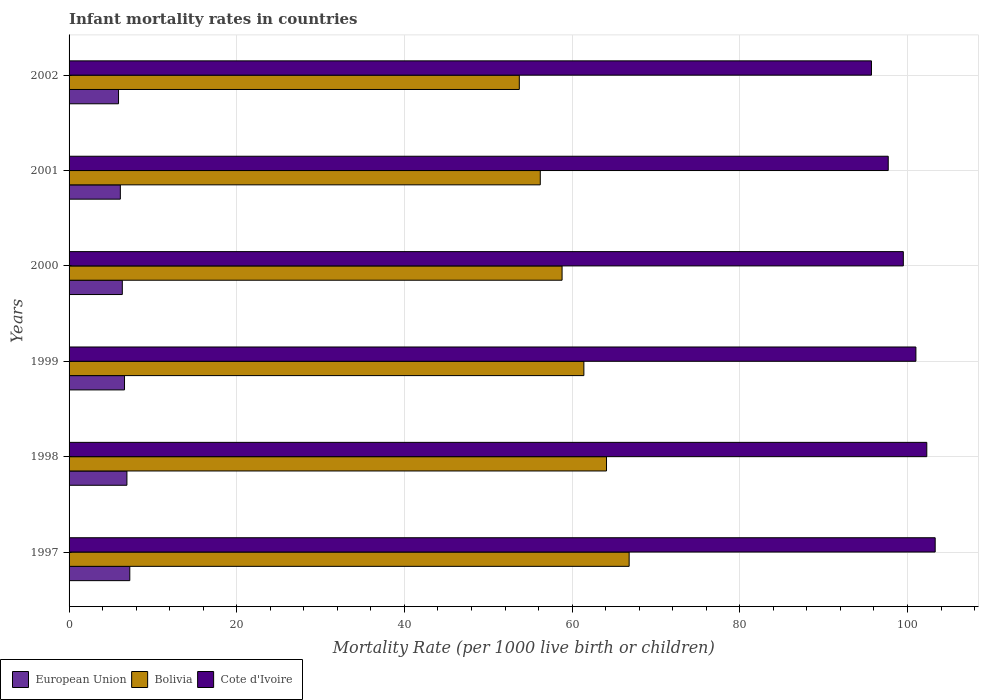How many different coloured bars are there?
Keep it short and to the point. 3. Are the number of bars per tick equal to the number of legend labels?
Keep it short and to the point. Yes. Are the number of bars on each tick of the Y-axis equal?
Make the answer very short. Yes. How many bars are there on the 5th tick from the top?
Your answer should be compact. 3. What is the label of the 1st group of bars from the top?
Keep it short and to the point. 2002. In how many cases, is the number of bars for a given year not equal to the number of legend labels?
Your answer should be very brief. 0. What is the infant mortality rate in Bolivia in 2002?
Ensure brevity in your answer.  53.7. Across all years, what is the maximum infant mortality rate in European Union?
Ensure brevity in your answer.  7.24. Across all years, what is the minimum infant mortality rate in European Union?
Offer a very short reply. 5.9. In which year was the infant mortality rate in European Union maximum?
Provide a short and direct response. 1997. What is the total infant mortality rate in European Union in the graph?
Make the answer very short. 39.12. What is the difference between the infant mortality rate in Bolivia in 2000 and that in 2001?
Your response must be concise. 2.6. What is the difference between the infant mortality rate in European Union in 1998 and the infant mortality rate in Cote d'Ivoire in 1997?
Give a very brief answer. -96.4. What is the average infant mortality rate in European Union per year?
Your answer should be compact. 6.52. In the year 1998, what is the difference between the infant mortality rate in European Union and infant mortality rate in Cote d'Ivoire?
Provide a short and direct response. -95.4. What is the ratio of the infant mortality rate in European Union in 1997 to that in 1998?
Ensure brevity in your answer.  1.05. Is the infant mortality rate in European Union in 2001 less than that in 2002?
Make the answer very short. No. Is the difference between the infant mortality rate in European Union in 1999 and 2002 greater than the difference between the infant mortality rate in Cote d'Ivoire in 1999 and 2002?
Keep it short and to the point. No. What is the difference between the highest and the second highest infant mortality rate in European Union?
Your response must be concise. 0.34. What is the difference between the highest and the lowest infant mortality rate in Cote d'Ivoire?
Your answer should be very brief. 7.6. In how many years, is the infant mortality rate in European Union greater than the average infant mortality rate in European Union taken over all years?
Give a very brief answer. 3. Is the sum of the infant mortality rate in Cote d'Ivoire in 1998 and 2002 greater than the maximum infant mortality rate in Bolivia across all years?
Offer a terse response. Yes. What does the 2nd bar from the top in 2000 represents?
Offer a very short reply. Bolivia. Is it the case that in every year, the sum of the infant mortality rate in European Union and infant mortality rate in Bolivia is greater than the infant mortality rate in Cote d'Ivoire?
Give a very brief answer. No. How many years are there in the graph?
Provide a short and direct response. 6. Does the graph contain any zero values?
Give a very brief answer. No. How many legend labels are there?
Keep it short and to the point. 3. What is the title of the graph?
Provide a succinct answer. Infant mortality rates in countries. Does "Fragile and conflict affected situations" appear as one of the legend labels in the graph?
Provide a short and direct response. No. What is the label or title of the X-axis?
Your answer should be compact. Mortality Rate (per 1000 live birth or children). What is the Mortality Rate (per 1000 live birth or children) of European Union in 1997?
Ensure brevity in your answer.  7.24. What is the Mortality Rate (per 1000 live birth or children) of Bolivia in 1997?
Keep it short and to the point. 66.8. What is the Mortality Rate (per 1000 live birth or children) in Cote d'Ivoire in 1997?
Provide a short and direct response. 103.3. What is the Mortality Rate (per 1000 live birth or children) in European Union in 1998?
Offer a very short reply. 6.9. What is the Mortality Rate (per 1000 live birth or children) in Bolivia in 1998?
Keep it short and to the point. 64.1. What is the Mortality Rate (per 1000 live birth or children) of Cote d'Ivoire in 1998?
Give a very brief answer. 102.3. What is the Mortality Rate (per 1000 live birth or children) in European Union in 1999?
Keep it short and to the point. 6.61. What is the Mortality Rate (per 1000 live birth or children) in Bolivia in 1999?
Give a very brief answer. 61.4. What is the Mortality Rate (per 1000 live birth or children) in Cote d'Ivoire in 1999?
Ensure brevity in your answer.  101. What is the Mortality Rate (per 1000 live birth or children) of European Union in 2000?
Ensure brevity in your answer.  6.35. What is the Mortality Rate (per 1000 live birth or children) in Bolivia in 2000?
Give a very brief answer. 58.8. What is the Mortality Rate (per 1000 live birth or children) in Cote d'Ivoire in 2000?
Ensure brevity in your answer.  99.5. What is the Mortality Rate (per 1000 live birth or children) in European Union in 2001?
Your response must be concise. 6.11. What is the Mortality Rate (per 1000 live birth or children) in Bolivia in 2001?
Your response must be concise. 56.2. What is the Mortality Rate (per 1000 live birth or children) in Cote d'Ivoire in 2001?
Keep it short and to the point. 97.7. What is the Mortality Rate (per 1000 live birth or children) of European Union in 2002?
Ensure brevity in your answer.  5.9. What is the Mortality Rate (per 1000 live birth or children) of Bolivia in 2002?
Give a very brief answer. 53.7. What is the Mortality Rate (per 1000 live birth or children) of Cote d'Ivoire in 2002?
Provide a succinct answer. 95.7. Across all years, what is the maximum Mortality Rate (per 1000 live birth or children) in European Union?
Provide a short and direct response. 7.24. Across all years, what is the maximum Mortality Rate (per 1000 live birth or children) of Bolivia?
Offer a very short reply. 66.8. Across all years, what is the maximum Mortality Rate (per 1000 live birth or children) in Cote d'Ivoire?
Ensure brevity in your answer.  103.3. Across all years, what is the minimum Mortality Rate (per 1000 live birth or children) of European Union?
Ensure brevity in your answer.  5.9. Across all years, what is the minimum Mortality Rate (per 1000 live birth or children) of Bolivia?
Make the answer very short. 53.7. Across all years, what is the minimum Mortality Rate (per 1000 live birth or children) of Cote d'Ivoire?
Offer a terse response. 95.7. What is the total Mortality Rate (per 1000 live birth or children) in European Union in the graph?
Ensure brevity in your answer.  39.12. What is the total Mortality Rate (per 1000 live birth or children) in Bolivia in the graph?
Keep it short and to the point. 361. What is the total Mortality Rate (per 1000 live birth or children) of Cote d'Ivoire in the graph?
Make the answer very short. 599.5. What is the difference between the Mortality Rate (per 1000 live birth or children) of European Union in 1997 and that in 1998?
Your answer should be very brief. 0.34. What is the difference between the Mortality Rate (per 1000 live birth or children) in Bolivia in 1997 and that in 1998?
Give a very brief answer. 2.7. What is the difference between the Mortality Rate (per 1000 live birth or children) of Cote d'Ivoire in 1997 and that in 1998?
Give a very brief answer. 1. What is the difference between the Mortality Rate (per 1000 live birth or children) of European Union in 1997 and that in 1999?
Ensure brevity in your answer.  0.63. What is the difference between the Mortality Rate (per 1000 live birth or children) in Cote d'Ivoire in 1997 and that in 1999?
Your answer should be compact. 2.3. What is the difference between the Mortality Rate (per 1000 live birth or children) in European Union in 1997 and that in 2000?
Your answer should be very brief. 0.89. What is the difference between the Mortality Rate (per 1000 live birth or children) in Cote d'Ivoire in 1997 and that in 2000?
Ensure brevity in your answer.  3.8. What is the difference between the Mortality Rate (per 1000 live birth or children) of European Union in 1997 and that in 2001?
Make the answer very short. 1.13. What is the difference between the Mortality Rate (per 1000 live birth or children) of Bolivia in 1997 and that in 2001?
Offer a terse response. 10.6. What is the difference between the Mortality Rate (per 1000 live birth or children) of Cote d'Ivoire in 1997 and that in 2001?
Keep it short and to the point. 5.6. What is the difference between the Mortality Rate (per 1000 live birth or children) of European Union in 1997 and that in 2002?
Offer a very short reply. 1.34. What is the difference between the Mortality Rate (per 1000 live birth or children) of Bolivia in 1997 and that in 2002?
Keep it short and to the point. 13.1. What is the difference between the Mortality Rate (per 1000 live birth or children) of Cote d'Ivoire in 1997 and that in 2002?
Give a very brief answer. 7.6. What is the difference between the Mortality Rate (per 1000 live birth or children) of European Union in 1998 and that in 1999?
Provide a succinct answer. 0.29. What is the difference between the Mortality Rate (per 1000 live birth or children) of European Union in 1998 and that in 2000?
Provide a succinct answer. 0.55. What is the difference between the Mortality Rate (per 1000 live birth or children) of Cote d'Ivoire in 1998 and that in 2000?
Provide a short and direct response. 2.8. What is the difference between the Mortality Rate (per 1000 live birth or children) of European Union in 1998 and that in 2001?
Offer a terse response. 0.79. What is the difference between the Mortality Rate (per 1000 live birth or children) of European Union in 1998 and that in 2002?
Keep it short and to the point. 1. What is the difference between the Mortality Rate (per 1000 live birth or children) in Bolivia in 1998 and that in 2002?
Your response must be concise. 10.4. What is the difference between the Mortality Rate (per 1000 live birth or children) of European Union in 1999 and that in 2000?
Provide a succinct answer. 0.26. What is the difference between the Mortality Rate (per 1000 live birth or children) of Cote d'Ivoire in 1999 and that in 2000?
Keep it short and to the point. 1.5. What is the difference between the Mortality Rate (per 1000 live birth or children) in European Union in 1999 and that in 2001?
Make the answer very short. 0.5. What is the difference between the Mortality Rate (per 1000 live birth or children) in European Union in 1999 and that in 2002?
Your answer should be compact. 0.71. What is the difference between the Mortality Rate (per 1000 live birth or children) in Bolivia in 1999 and that in 2002?
Your answer should be very brief. 7.7. What is the difference between the Mortality Rate (per 1000 live birth or children) of Cote d'Ivoire in 1999 and that in 2002?
Make the answer very short. 5.3. What is the difference between the Mortality Rate (per 1000 live birth or children) of European Union in 2000 and that in 2001?
Ensure brevity in your answer.  0.23. What is the difference between the Mortality Rate (per 1000 live birth or children) in Cote d'Ivoire in 2000 and that in 2001?
Ensure brevity in your answer.  1.8. What is the difference between the Mortality Rate (per 1000 live birth or children) in European Union in 2000 and that in 2002?
Ensure brevity in your answer.  0.45. What is the difference between the Mortality Rate (per 1000 live birth or children) in Cote d'Ivoire in 2000 and that in 2002?
Ensure brevity in your answer.  3.8. What is the difference between the Mortality Rate (per 1000 live birth or children) of European Union in 2001 and that in 2002?
Ensure brevity in your answer.  0.21. What is the difference between the Mortality Rate (per 1000 live birth or children) of European Union in 1997 and the Mortality Rate (per 1000 live birth or children) of Bolivia in 1998?
Your answer should be very brief. -56.86. What is the difference between the Mortality Rate (per 1000 live birth or children) in European Union in 1997 and the Mortality Rate (per 1000 live birth or children) in Cote d'Ivoire in 1998?
Provide a short and direct response. -95.06. What is the difference between the Mortality Rate (per 1000 live birth or children) of Bolivia in 1997 and the Mortality Rate (per 1000 live birth or children) of Cote d'Ivoire in 1998?
Make the answer very short. -35.5. What is the difference between the Mortality Rate (per 1000 live birth or children) of European Union in 1997 and the Mortality Rate (per 1000 live birth or children) of Bolivia in 1999?
Provide a short and direct response. -54.16. What is the difference between the Mortality Rate (per 1000 live birth or children) of European Union in 1997 and the Mortality Rate (per 1000 live birth or children) of Cote d'Ivoire in 1999?
Your response must be concise. -93.76. What is the difference between the Mortality Rate (per 1000 live birth or children) of Bolivia in 1997 and the Mortality Rate (per 1000 live birth or children) of Cote d'Ivoire in 1999?
Your answer should be very brief. -34.2. What is the difference between the Mortality Rate (per 1000 live birth or children) in European Union in 1997 and the Mortality Rate (per 1000 live birth or children) in Bolivia in 2000?
Offer a very short reply. -51.56. What is the difference between the Mortality Rate (per 1000 live birth or children) in European Union in 1997 and the Mortality Rate (per 1000 live birth or children) in Cote d'Ivoire in 2000?
Ensure brevity in your answer.  -92.26. What is the difference between the Mortality Rate (per 1000 live birth or children) in Bolivia in 1997 and the Mortality Rate (per 1000 live birth or children) in Cote d'Ivoire in 2000?
Your answer should be very brief. -32.7. What is the difference between the Mortality Rate (per 1000 live birth or children) in European Union in 1997 and the Mortality Rate (per 1000 live birth or children) in Bolivia in 2001?
Provide a short and direct response. -48.96. What is the difference between the Mortality Rate (per 1000 live birth or children) of European Union in 1997 and the Mortality Rate (per 1000 live birth or children) of Cote d'Ivoire in 2001?
Give a very brief answer. -90.46. What is the difference between the Mortality Rate (per 1000 live birth or children) in Bolivia in 1997 and the Mortality Rate (per 1000 live birth or children) in Cote d'Ivoire in 2001?
Provide a succinct answer. -30.9. What is the difference between the Mortality Rate (per 1000 live birth or children) in European Union in 1997 and the Mortality Rate (per 1000 live birth or children) in Bolivia in 2002?
Offer a very short reply. -46.46. What is the difference between the Mortality Rate (per 1000 live birth or children) of European Union in 1997 and the Mortality Rate (per 1000 live birth or children) of Cote d'Ivoire in 2002?
Make the answer very short. -88.46. What is the difference between the Mortality Rate (per 1000 live birth or children) in Bolivia in 1997 and the Mortality Rate (per 1000 live birth or children) in Cote d'Ivoire in 2002?
Make the answer very short. -28.9. What is the difference between the Mortality Rate (per 1000 live birth or children) in European Union in 1998 and the Mortality Rate (per 1000 live birth or children) in Bolivia in 1999?
Keep it short and to the point. -54.5. What is the difference between the Mortality Rate (per 1000 live birth or children) in European Union in 1998 and the Mortality Rate (per 1000 live birth or children) in Cote d'Ivoire in 1999?
Provide a succinct answer. -94.1. What is the difference between the Mortality Rate (per 1000 live birth or children) in Bolivia in 1998 and the Mortality Rate (per 1000 live birth or children) in Cote d'Ivoire in 1999?
Your answer should be compact. -36.9. What is the difference between the Mortality Rate (per 1000 live birth or children) in European Union in 1998 and the Mortality Rate (per 1000 live birth or children) in Bolivia in 2000?
Give a very brief answer. -51.9. What is the difference between the Mortality Rate (per 1000 live birth or children) of European Union in 1998 and the Mortality Rate (per 1000 live birth or children) of Cote d'Ivoire in 2000?
Your response must be concise. -92.6. What is the difference between the Mortality Rate (per 1000 live birth or children) in Bolivia in 1998 and the Mortality Rate (per 1000 live birth or children) in Cote d'Ivoire in 2000?
Provide a succinct answer. -35.4. What is the difference between the Mortality Rate (per 1000 live birth or children) in European Union in 1998 and the Mortality Rate (per 1000 live birth or children) in Bolivia in 2001?
Offer a terse response. -49.3. What is the difference between the Mortality Rate (per 1000 live birth or children) of European Union in 1998 and the Mortality Rate (per 1000 live birth or children) of Cote d'Ivoire in 2001?
Keep it short and to the point. -90.8. What is the difference between the Mortality Rate (per 1000 live birth or children) of Bolivia in 1998 and the Mortality Rate (per 1000 live birth or children) of Cote d'Ivoire in 2001?
Keep it short and to the point. -33.6. What is the difference between the Mortality Rate (per 1000 live birth or children) of European Union in 1998 and the Mortality Rate (per 1000 live birth or children) of Bolivia in 2002?
Ensure brevity in your answer.  -46.8. What is the difference between the Mortality Rate (per 1000 live birth or children) in European Union in 1998 and the Mortality Rate (per 1000 live birth or children) in Cote d'Ivoire in 2002?
Keep it short and to the point. -88.8. What is the difference between the Mortality Rate (per 1000 live birth or children) in Bolivia in 1998 and the Mortality Rate (per 1000 live birth or children) in Cote d'Ivoire in 2002?
Your answer should be compact. -31.6. What is the difference between the Mortality Rate (per 1000 live birth or children) of European Union in 1999 and the Mortality Rate (per 1000 live birth or children) of Bolivia in 2000?
Your answer should be compact. -52.19. What is the difference between the Mortality Rate (per 1000 live birth or children) in European Union in 1999 and the Mortality Rate (per 1000 live birth or children) in Cote d'Ivoire in 2000?
Ensure brevity in your answer.  -92.89. What is the difference between the Mortality Rate (per 1000 live birth or children) in Bolivia in 1999 and the Mortality Rate (per 1000 live birth or children) in Cote d'Ivoire in 2000?
Your answer should be compact. -38.1. What is the difference between the Mortality Rate (per 1000 live birth or children) in European Union in 1999 and the Mortality Rate (per 1000 live birth or children) in Bolivia in 2001?
Offer a terse response. -49.59. What is the difference between the Mortality Rate (per 1000 live birth or children) of European Union in 1999 and the Mortality Rate (per 1000 live birth or children) of Cote d'Ivoire in 2001?
Give a very brief answer. -91.09. What is the difference between the Mortality Rate (per 1000 live birth or children) of Bolivia in 1999 and the Mortality Rate (per 1000 live birth or children) of Cote d'Ivoire in 2001?
Provide a succinct answer. -36.3. What is the difference between the Mortality Rate (per 1000 live birth or children) in European Union in 1999 and the Mortality Rate (per 1000 live birth or children) in Bolivia in 2002?
Give a very brief answer. -47.09. What is the difference between the Mortality Rate (per 1000 live birth or children) in European Union in 1999 and the Mortality Rate (per 1000 live birth or children) in Cote d'Ivoire in 2002?
Make the answer very short. -89.09. What is the difference between the Mortality Rate (per 1000 live birth or children) of Bolivia in 1999 and the Mortality Rate (per 1000 live birth or children) of Cote d'Ivoire in 2002?
Your answer should be compact. -34.3. What is the difference between the Mortality Rate (per 1000 live birth or children) of European Union in 2000 and the Mortality Rate (per 1000 live birth or children) of Bolivia in 2001?
Offer a terse response. -49.85. What is the difference between the Mortality Rate (per 1000 live birth or children) in European Union in 2000 and the Mortality Rate (per 1000 live birth or children) in Cote d'Ivoire in 2001?
Keep it short and to the point. -91.35. What is the difference between the Mortality Rate (per 1000 live birth or children) of Bolivia in 2000 and the Mortality Rate (per 1000 live birth or children) of Cote d'Ivoire in 2001?
Offer a very short reply. -38.9. What is the difference between the Mortality Rate (per 1000 live birth or children) in European Union in 2000 and the Mortality Rate (per 1000 live birth or children) in Bolivia in 2002?
Your answer should be compact. -47.35. What is the difference between the Mortality Rate (per 1000 live birth or children) in European Union in 2000 and the Mortality Rate (per 1000 live birth or children) in Cote d'Ivoire in 2002?
Offer a terse response. -89.35. What is the difference between the Mortality Rate (per 1000 live birth or children) of Bolivia in 2000 and the Mortality Rate (per 1000 live birth or children) of Cote d'Ivoire in 2002?
Give a very brief answer. -36.9. What is the difference between the Mortality Rate (per 1000 live birth or children) in European Union in 2001 and the Mortality Rate (per 1000 live birth or children) in Bolivia in 2002?
Your response must be concise. -47.59. What is the difference between the Mortality Rate (per 1000 live birth or children) of European Union in 2001 and the Mortality Rate (per 1000 live birth or children) of Cote d'Ivoire in 2002?
Offer a terse response. -89.59. What is the difference between the Mortality Rate (per 1000 live birth or children) in Bolivia in 2001 and the Mortality Rate (per 1000 live birth or children) in Cote d'Ivoire in 2002?
Provide a succinct answer. -39.5. What is the average Mortality Rate (per 1000 live birth or children) of European Union per year?
Make the answer very short. 6.52. What is the average Mortality Rate (per 1000 live birth or children) in Bolivia per year?
Offer a terse response. 60.17. What is the average Mortality Rate (per 1000 live birth or children) in Cote d'Ivoire per year?
Give a very brief answer. 99.92. In the year 1997, what is the difference between the Mortality Rate (per 1000 live birth or children) of European Union and Mortality Rate (per 1000 live birth or children) of Bolivia?
Give a very brief answer. -59.56. In the year 1997, what is the difference between the Mortality Rate (per 1000 live birth or children) in European Union and Mortality Rate (per 1000 live birth or children) in Cote d'Ivoire?
Ensure brevity in your answer.  -96.06. In the year 1997, what is the difference between the Mortality Rate (per 1000 live birth or children) of Bolivia and Mortality Rate (per 1000 live birth or children) of Cote d'Ivoire?
Your answer should be very brief. -36.5. In the year 1998, what is the difference between the Mortality Rate (per 1000 live birth or children) in European Union and Mortality Rate (per 1000 live birth or children) in Bolivia?
Make the answer very short. -57.2. In the year 1998, what is the difference between the Mortality Rate (per 1000 live birth or children) of European Union and Mortality Rate (per 1000 live birth or children) of Cote d'Ivoire?
Provide a short and direct response. -95.4. In the year 1998, what is the difference between the Mortality Rate (per 1000 live birth or children) in Bolivia and Mortality Rate (per 1000 live birth or children) in Cote d'Ivoire?
Your response must be concise. -38.2. In the year 1999, what is the difference between the Mortality Rate (per 1000 live birth or children) of European Union and Mortality Rate (per 1000 live birth or children) of Bolivia?
Ensure brevity in your answer.  -54.79. In the year 1999, what is the difference between the Mortality Rate (per 1000 live birth or children) of European Union and Mortality Rate (per 1000 live birth or children) of Cote d'Ivoire?
Keep it short and to the point. -94.39. In the year 1999, what is the difference between the Mortality Rate (per 1000 live birth or children) of Bolivia and Mortality Rate (per 1000 live birth or children) of Cote d'Ivoire?
Ensure brevity in your answer.  -39.6. In the year 2000, what is the difference between the Mortality Rate (per 1000 live birth or children) of European Union and Mortality Rate (per 1000 live birth or children) of Bolivia?
Your response must be concise. -52.45. In the year 2000, what is the difference between the Mortality Rate (per 1000 live birth or children) of European Union and Mortality Rate (per 1000 live birth or children) of Cote d'Ivoire?
Keep it short and to the point. -93.15. In the year 2000, what is the difference between the Mortality Rate (per 1000 live birth or children) of Bolivia and Mortality Rate (per 1000 live birth or children) of Cote d'Ivoire?
Your response must be concise. -40.7. In the year 2001, what is the difference between the Mortality Rate (per 1000 live birth or children) in European Union and Mortality Rate (per 1000 live birth or children) in Bolivia?
Provide a short and direct response. -50.09. In the year 2001, what is the difference between the Mortality Rate (per 1000 live birth or children) of European Union and Mortality Rate (per 1000 live birth or children) of Cote d'Ivoire?
Make the answer very short. -91.59. In the year 2001, what is the difference between the Mortality Rate (per 1000 live birth or children) in Bolivia and Mortality Rate (per 1000 live birth or children) in Cote d'Ivoire?
Your answer should be compact. -41.5. In the year 2002, what is the difference between the Mortality Rate (per 1000 live birth or children) in European Union and Mortality Rate (per 1000 live birth or children) in Bolivia?
Give a very brief answer. -47.8. In the year 2002, what is the difference between the Mortality Rate (per 1000 live birth or children) of European Union and Mortality Rate (per 1000 live birth or children) of Cote d'Ivoire?
Provide a succinct answer. -89.8. In the year 2002, what is the difference between the Mortality Rate (per 1000 live birth or children) of Bolivia and Mortality Rate (per 1000 live birth or children) of Cote d'Ivoire?
Offer a terse response. -42. What is the ratio of the Mortality Rate (per 1000 live birth or children) of European Union in 1997 to that in 1998?
Offer a terse response. 1.05. What is the ratio of the Mortality Rate (per 1000 live birth or children) of Bolivia in 1997 to that in 1998?
Your answer should be compact. 1.04. What is the ratio of the Mortality Rate (per 1000 live birth or children) of Cote d'Ivoire in 1997 to that in 1998?
Your answer should be very brief. 1.01. What is the ratio of the Mortality Rate (per 1000 live birth or children) of European Union in 1997 to that in 1999?
Ensure brevity in your answer.  1.1. What is the ratio of the Mortality Rate (per 1000 live birth or children) in Bolivia in 1997 to that in 1999?
Your response must be concise. 1.09. What is the ratio of the Mortality Rate (per 1000 live birth or children) in Cote d'Ivoire in 1997 to that in 1999?
Your answer should be compact. 1.02. What is the ratio of the Mortality Rate (per 1000 live birth or children) in European Union in 1997 to that in 2000?
Keep it short and to the point. 1.14. What is the ratio of the Mortality Rate (per 1000 live birth or children) in Bolivia in 1997 to that in 2000?
Keep it short and to the point. 1.14. What is the ratio of the Mortality Rate (per 1000 live birth or children) of Cote d'Ivoire in 1997 to that in 2000?
Provide a short and direct response. 1.04. What is the ratio of the Mortality Rate (per 1000 live birth or children) in European Union in 1997 to that in 2001?
Offer a very short reply. 1.18. What is the ratio of the Mortality Rate (per 1000 live birth or children) of Bolivia in 1997 to that in 2001?
Your response must be concise. 1.19. What is the ratio of the Mortality Rate (per 1000 live birth or children) of Cote d'Ivoire in 1997 to that in 2001?
Your answer should be very brief. 1.06. What is the ratio of the Mortality Rate (per 1000 live birth or children) of European Union in 1997 to that in 2002?
Your response must be concise. 1.23. What is the ratio of the Mortality Rate (per 1000 live birth or children) in Bolivia in 1997 to that in 2002?
Your response must be concise. 1.24. What is the ratio of the Mortality Rate (per 1000 live birth or children) of Cote d'Ivoire in 1997 to that in 2002?
Keep it short and to the point. 1.08. What is the ratio of the Mortality Rate (per 1000 live birth or children) of European Union in 1998 to that in 1999?
Offer a terse response. 1.04. What is the ratio of the Mortality Rate (per 1000 live birth or children) in Bolivia in 1998 to that in 1999?
Offer a terse response. 1.04. What is the ratio of the Mortality Rate (per 1000 live birth or children) in Cote d'Ivoire in 1998 to that in 1999?
Ensure brevity in your answer.  1.01. What is the ratio of the Mortality Rate (per 1000 live birth or children) in European Union in 1998 to that in 2000?
Give a very brief answer. 1.09. What is the ratio of the Mortality Rate (per 1000 live birth or children) of Bolivia in 1998 to that in 2000?
Keep it short and to the point. 1.09. What is the ratio of the Mortality Rate (per 1000 live birth or children) of Cote d'Ivoire in 1998 to that in 2000?
Your answer should be very brief. 1.03. What is the ratio of the Mortality Rate (per 1000 live birth or children) of European Union in 1998 to that in 2001?
Make the answer very short. 1.13. What is the ratio of the Mortality Rate (per 1000 live birth or children) of Bolivia in 1998 to that in 2001?
Offer a very short reply. 1.14. What is the ratio of the Mortality Rate (per 1000 live birth or children) of Cote d'Ivoire in 1998 to that in 2001?
Your answer should be compact. 1.05. What is the ratio of the Mortality Rate (per 1000 live birth or children) in European Union in 1998 to that in 2002?
Your answer should be compact. 1.17. What is the ratio of the Mortality Rate (per 1000 live birth or children) in Bolivia in 1998 to that in 2002?
Provide a short and direct response. 1.19. What is the ratio of the Mortality Rate (per 1000 live birth or children) of Cote d'Ivoire in 1998 to that in 2002?
Keep it short and to the point. 1.07. What is the ratio of the Mortality Rate (per 1000 live birth or children) of European Union in 1999 to that in 2000?
Give a very brief answer. 1.04. What is the ratio of the Mortality Rate (per 1000 live birth or children) in Bolivia in 1999 to that in 2000?
Give a very brief answer. 1.04. What is the ratio of the Mortality Rate (per 1000 live birth or children) in Cote d'Ivoire in 1999 to that in 2000?
Keep it short and to the point. 1.02. What is the ratio of the Mortality Rate (per 1000 live birth or children) in European Union in 1999 to that in 2001?
Provide a succinct answer. 1.08. What is the ratio of the Mortality Rate (per 1000 live birth or children) in Bolivia in 1999 to that in 2001?
Ensure brevity in your answer.  1.09. What is the ratio of the Mortality Rate (per 1000 live birth or children) of Cote d'Ivoire in 1999 to that in 2001?
Give a very brief answer. 1.03. What is the ratio of the Mortality Rate (per 1000 live birth or children) in European Union in 1999 to that in 2002?
Make the answer very short. 1.12. What is the ratio of the Mortality Rate (per 1000 live birth or children) in Bolivia in 1999 to that in 2002?
Your response must be concise. 1.14. What is the ratio of the Mortality Rate (per 1000 live birth or children) in Cote d'Ivoire in 1999 to that in 2002?
Offer a terse response. 1.06. What is the ratio of the Mortality Rate (per 1000 live birth or children) of European Union in 2000 to that in 2001?
Provide a short and direct response. 1.04. What is the ratio of the Mortality Rate (per 1000 live birth or children) of Bolivia in 2000 to that in 2001?
Your answer should be compact. 1.05. What is the ratio of the Mortality Rate (per 1000 live birth or children) in Cote d'Ivoire in 2000 to that in 2001?
Provide a short and direct response. 1.02. What is the ratio of the Mortality Rate (per 1000 live birth or children) of European Union in 2000 to that in 2002?
Give a very brief answer. 1.08. What is the ratio of the Mortality Rate (per 1000 live birth or children) in Bolivia in 2000 to that in 2002?
Keep it short and to the point. 1.09. What is the ratio of the Mortality Rate (per 1000 live birth or children) in Cote d'Ivoire in 2000 to that in 2002?
Ensure brevity in your answer.  1.04. What is the ratio of the Mortality Rate (per 1000 live birth or children) of European Union in 2001 to that in 2002?
Provide a succinct answer. 1.04. What is the ratio of the Mortality Rate (per 1000 live birth or children) in Bolivia in 2001 to that in 2002?
Make the answer very short. 1.05. What is the ratio of the Mortality Rate (per 1000 live birth or children) of Cote d'Ivoire in 2001 to that in 2002?
Offer a very short reply. 1.02. What is the difference between the highest and the second highest Mortality Rate (per 1000 live birth or children) of European Union?
Make the answer very short. 0.34. What is the difference between the highest and the second highest Mortality Rate (per 1000 live birth or children) in Cote d'Ivoire?
Give a very brief answer. 1. What is the difference between the highest and the lowest Mortality Rate (per 1000 live birth or children) in European Union?
Your answer should be very brief. 1.34. What is the difference between the highest and the lowest Mortality Rate (per 1000 live birth or children) in Bolivia?
Your answer should be compact. 13.1. 